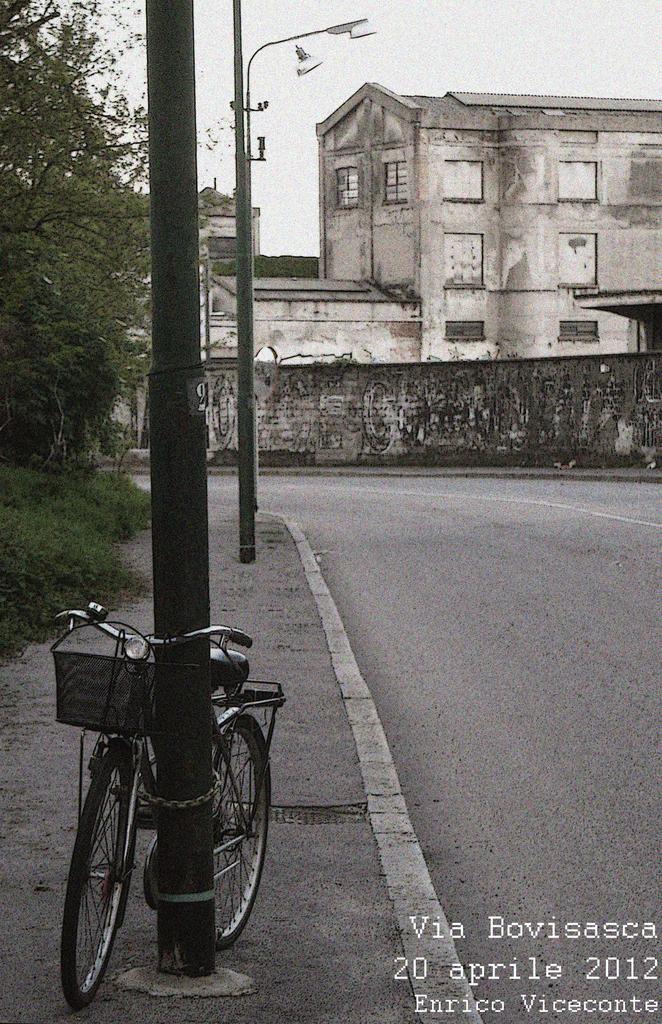Please provide a concise description of this image. In this picture I can see there is a bicycle tied her to the pole and there are some buildings and trees. The sky is clear. 